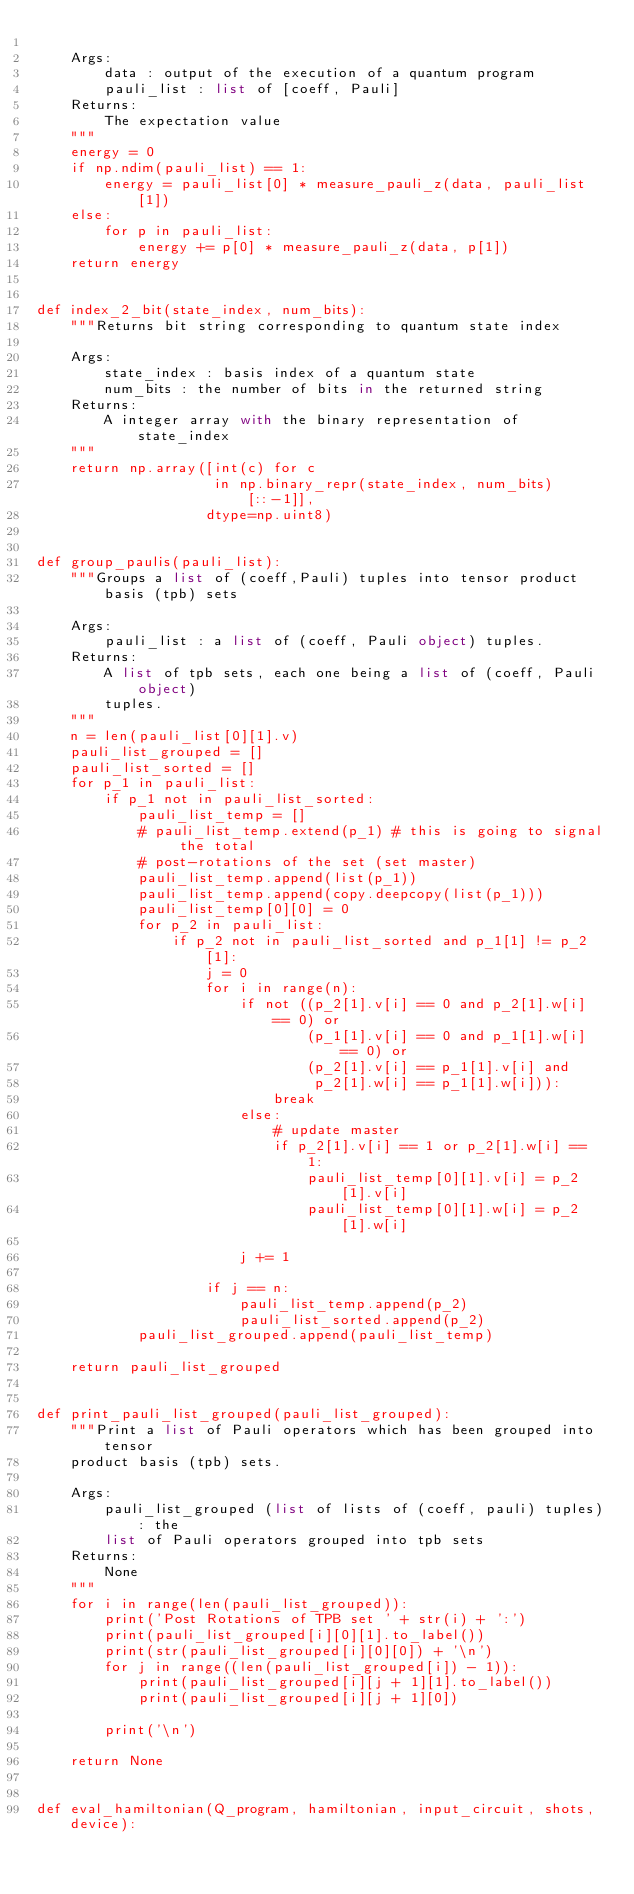<code> <loc_0><loc_0><loc_500><loc_500><_Python_>
    Args:
        data : output of the execution of a quantum program
        pauli_list : list of [coeff, Pauli]
    Returns:
        The expectation value
    """
    energy = 0
    if np.ndim(pauli_list) == 1:
        energy = pauli_list[0] * measure_pauli_z(data, pauli_list[1])
    else:
        for p in pauli_list:
            energy += p[0] * measure_pauli_z(data, p[1])
    return energy


def index_2_bit(state_index, num_bits):
    """Returns bit string corresponding to quantum state index

    Args:
        state_index : basis index of a quantum state
        num_bits : the number of bits in the returned string
    Returns:
        A integer array with the binary representation of state_index
    """
    return np.array([int(c) for c
                     in np.binary_repr(state_index, num_bits)[::-1]],
                    dtype=np.uint8)


def group_paulis(pauli_list):
    """Groups a list of (coeff,Pauli) tuples into tensor product basis (tpb) sets

    Args:
        pauli_list : a list of (coeff, Pauli object) tuples.
    Returns:
        A list of tpb sets, each one being a list of (coeff, Pauli object)
        tuples.
    """
    n = len(pauli_list[0][1].v)
    pauli_list_grouped = []
    pauli_list_sorted = []
    for p_1 in pauli_list:
        if p_1 not in pauli_list_sorted:
            pauli_list_temp = []
            # pauli_list_temp.extend(p_1) # this is going to signal the total
            # post-rotations of the set (set master)
            pauli_list_temp.append(list(p_1))
            pauli_list_temp.append(copy.deepcopy(list(p_1)))
            pauli_list_temp[0][0] = 0
            for p_2 in pauli_list:
                if p_2 not in pauli_list_sorted and p_1[1] != p_2[1]:
                    j = 0
                    for i in range(n):
                        if not ((p_2[1].v[i] == 0 and p_2[1].w[i] == 0) or
                                (p_1[1].v[i] == 0 and p_1[1].w[i] == 0) or
                                (p_2[1].v[i] == p_1[1].v[i] and
                                 p_2[1].w[i] == p_1[1].w[i])):
                            break
                        else:
                            # update master
                            if p_2[1].v[i] == 1 or p_2[1].w[i] == 1:
                                pauli_list_temp[0][1].v[i] = p_2[1].v[i]
                                pauli_list_temp[0][1].w[i] = p_2[1].w[i]

                        j += 1

                    if j == n:
                        pauli_list_temp.append(p_2)
                        pauli_list_sorted.append(p_2)
            pauli_list_grouped.append(pauli_list_temp)

    return pauli_list_grouped


def print_pauli_list_grouped(pauli_list_grouped):
    """Print a list of Pauli operators which has been grouped into tensor
    product basis (tpb) sets.

    Args:
        pauli_list_grouped (list of lists of (coeff, pauli) tuples): the
        list of Pauli operators grouped into tpb sets
    Returns:
        None
    """
    for i in range(len(pauli_list_grouped)):
        print('Post Rotations of TPB set ' + str(i) + ':')
        print(pauli_list_grouped[i][0][1].to_label())
        print(str(pauli_list_grouped[i][0][0]) + '\n')
        for j in range((len(pauli_list_grouped[i]) - 1)):
            print(pauli_list_grouped[i][j + 1][1].to_label())
            print(pauli_list_grouped[i][j + 1][0])

        print('\n')

    return None


def eval_hamiltonian(Q_program, hamiltonian, input_circuit, shots, device):</code> 